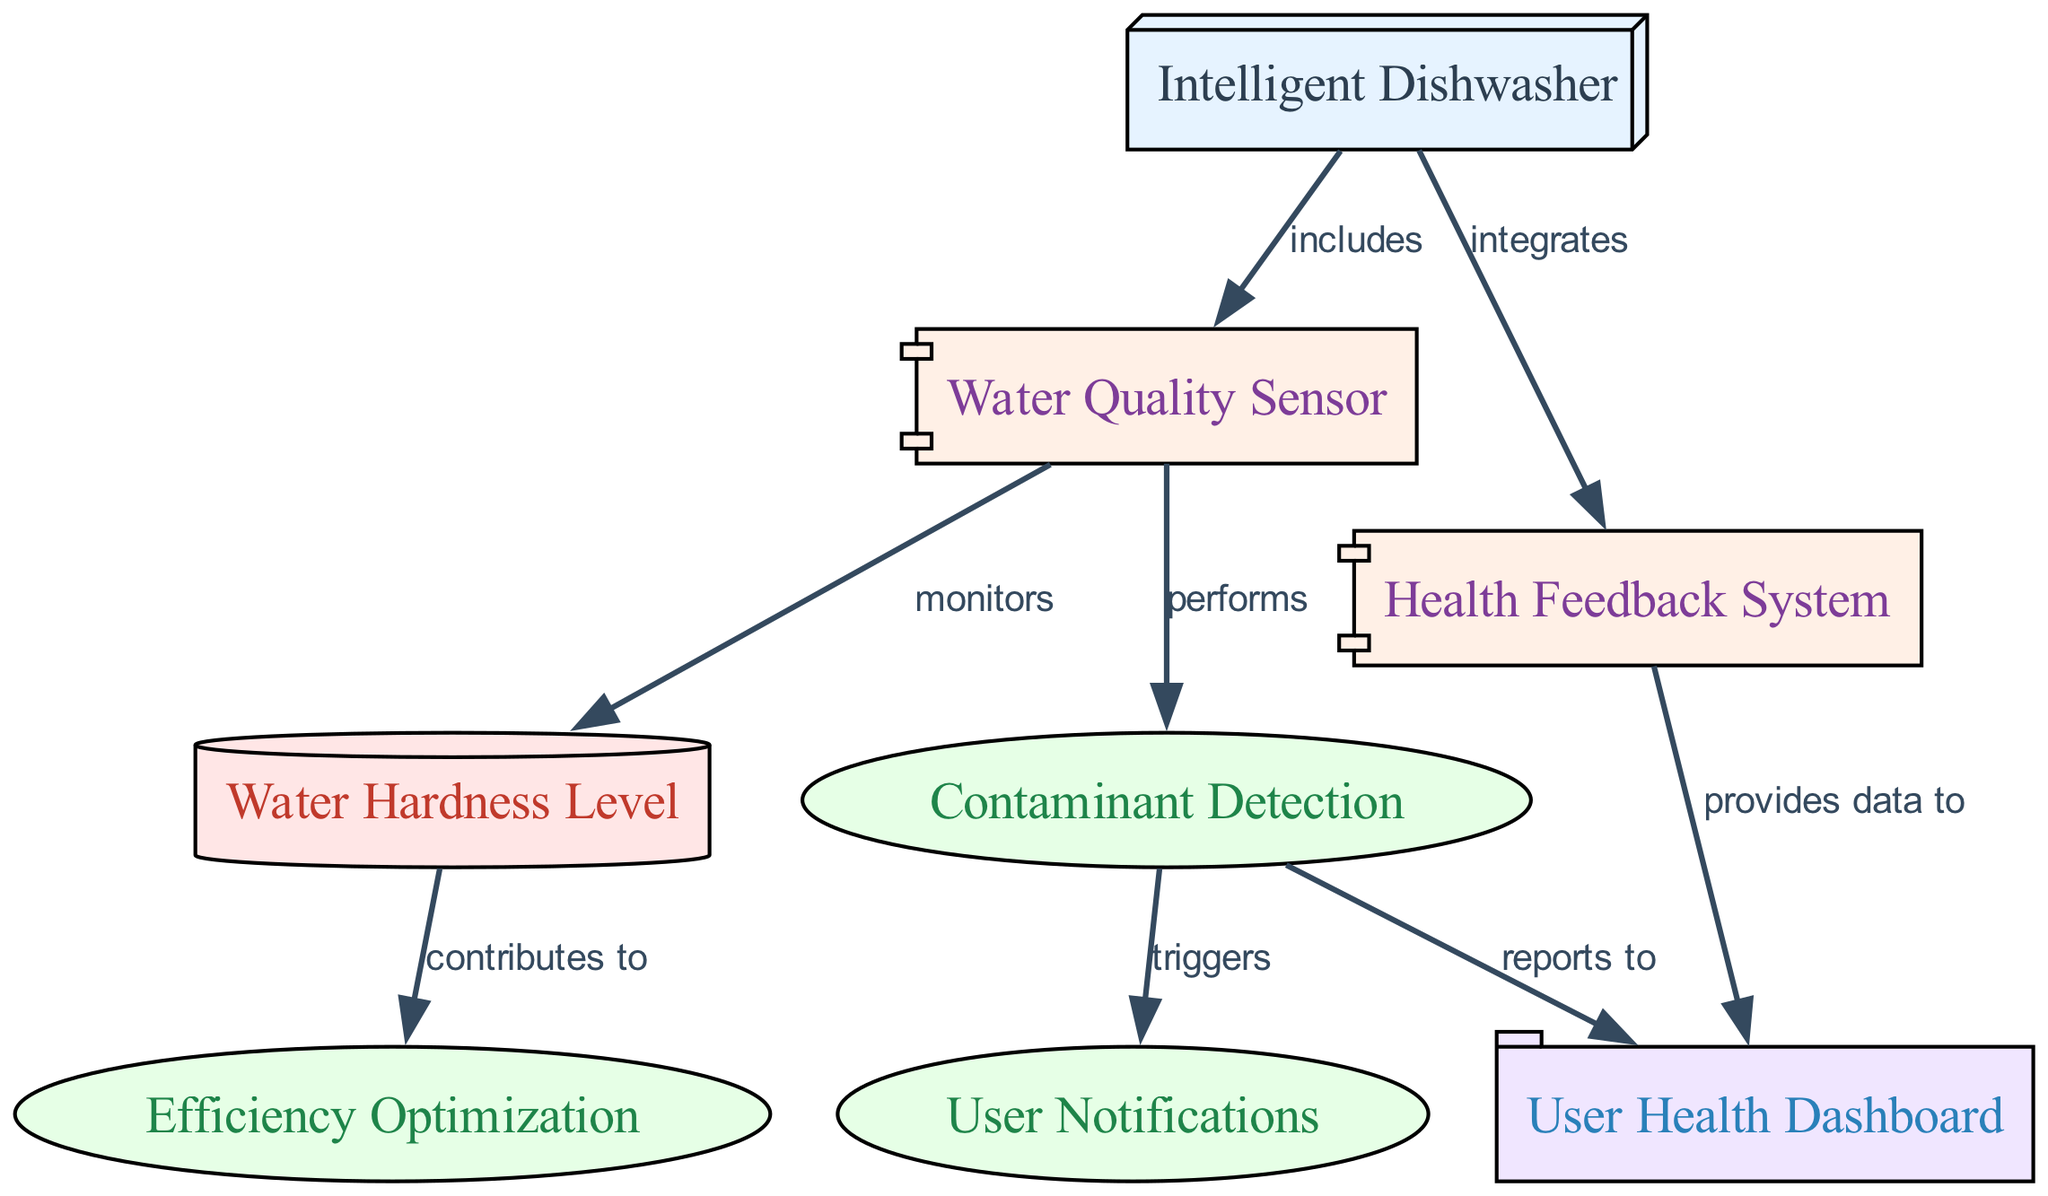What is the primary function of the Intelligent Dishwasher? The primary function of the Intelligent Dishwasher encapsulates its role within the diagram, positioning it as a central appliance that integrates various components for enhanced performance.
Answer: appliance How many components are included in the Intelligent Dishwasher? The diagram features two components connected to the Intelligent Dishwasher: the Water Quality Sensor and the Health Feedback System.
Answer: 2 What type of data does the Water Quality Sensor monitor? The Water Quality Sensor is specifically designed to monitor the Water Hardness Level, providing critical data for the functioning of the Intelligent Dishwasher.
Answer: Water Hardness Level What does the Contaminant Detection function report to? The Contaminant Detection function is directly linked to the User Health Dashboard, indicating that it reports its findings, such as harmful substances, to inform the user about their water quality.
Answer: User Health Dashboard Which function triggers User Notifications? The function of Contaminant Detection is responsible for triggering User Notifications when contaminants are detected, demonstrating the appliance's focus on health and safety.
Answer: Contaminant Detection How does Water Hardness Level contribute to the dishwasher's efficiency optimization? The Water Hardness Level is essential in informing the Efficiency Optimization function, helping the dishwasher adjust its washing cycles based on the hardness of the water being used.
Answer: contributes to What kind of interface does the Health Feedback System provide data to? The Health Feedback System provides data to the User Health Dashboard, highlighting how user-friendly interfaces are integrated into the Intelligent Dishwasher's design for better health monitoring.
Answer: User Health Dashboard What relationship exists between the Intelligent Dishwasher and the components? The diagram illustrates that the Intelligent Dishwasher includes the Water Quality Sensor and integrates the Health Feedback System, showcasing its multifunctional role as an advanced kitchen appliance.
Answer: includes, integrates 